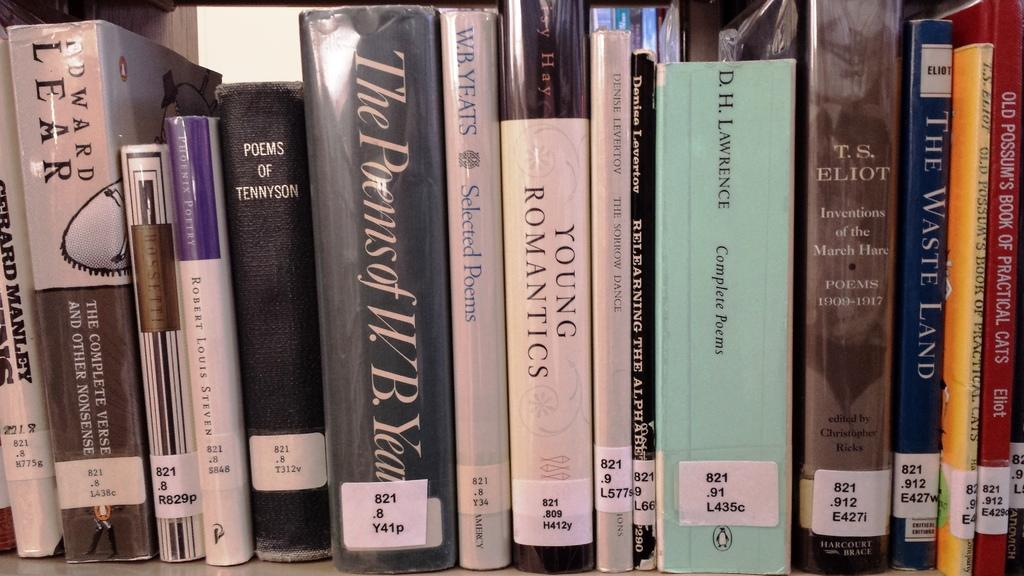What objects can be seen in the image? There are books in the image. Where are the books located? The books are placed on a bookshelf. What type of slope can be seen in the image? There is no slope present in the image; it features books on a bookshelf. What message of peace or hope can be found in the image? The image does not convey any specific message of peace or hope, as it only shows books on a bookshelf. 